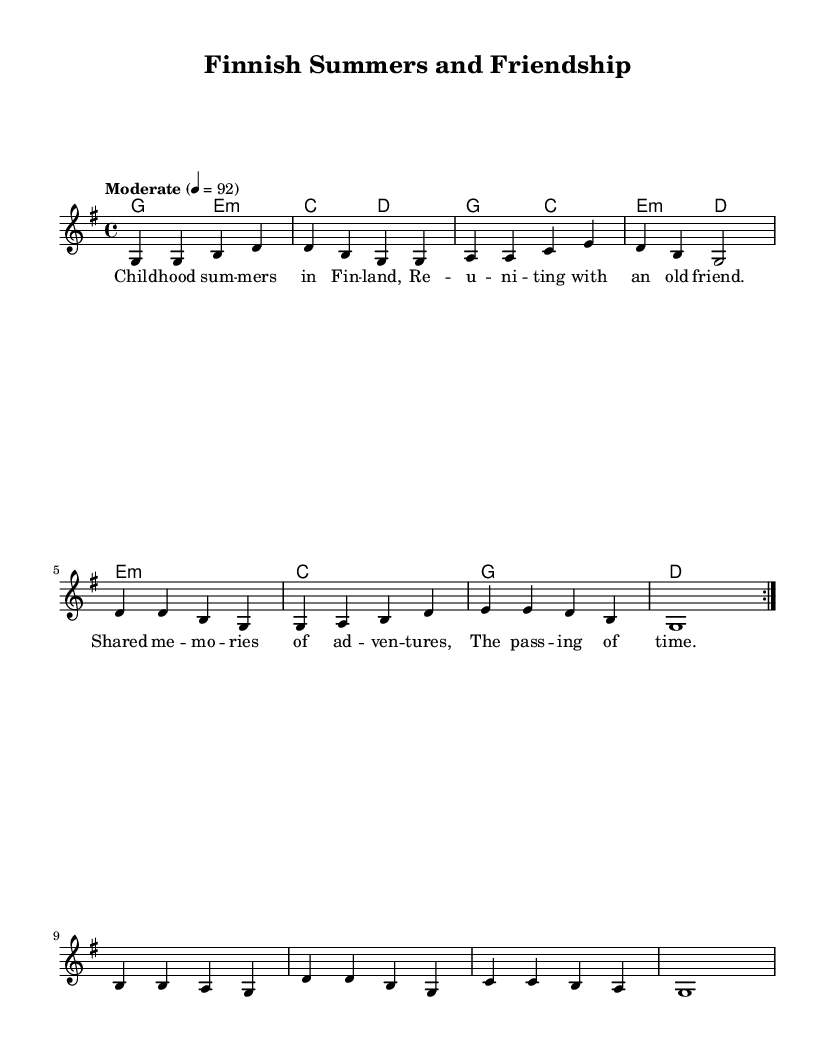What is the key signature of this music? The key signature indicates G major, which has one sharp (F#). This can be identified from the note heads associated with the melody and harmonies that align with G major scales.
Answer: G major What is the time signature of the piece? The time signature is 4/4, which is displayed at the beginning of the score. Each measure contains four beats, allowing for a steady rhythmic pattern typical in country music.
Answer: 4/4 What is the tempo marking of this music? The tempo marking is indicated as "Moderate" with a metronome marking of quarter note equals 92. This provides guidance on the speed at which the piece should be played, characteristic of a laid-back country feel.
Answer: Moderate, 92 How many verses are repeated in the melody? There are two verses repeated in the melody, as indicated by the repeat markings (volta) that instruct the performer to go back to the beginning after the first playthrough.
Answer: Two What is the theme of the lyrics in this piece? The lyrics focus on childhood summers in Finland and the joy of reconnecting with an old friend through shared memories, which is typical of nostalgic country songs that evoke personal stories and emotions.
Answer: Reconnecting with an old friend What type of harmony is used in this music? The harmony used is a combination of major and minor chords, offering a typical country sound that blends melancholy and uplifting feelings, as evidenced by the chord progression.
Answer: Major and minor chords What do the lyrics suggest about the memories shared? The lyrics suggest warm and positive memories, emphasizing adventure and the passage of time, which resonates with the theme of nostalgia often found in country music.
Answer: Warm and positive memories 